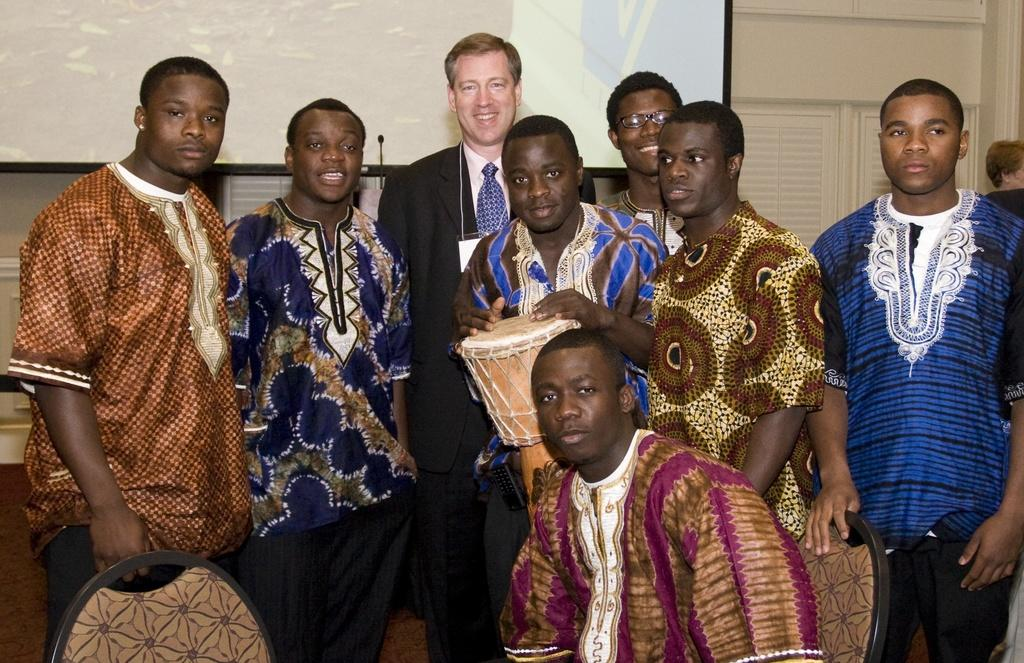How many people are in the image? There is a group of people in the image, but the exact number cannot be determined from the provided facts. What are the people sitting on in the image? There are chairs in the image, which suggests that the people may be sitting on them. What is the main object in the image? There is an object in the image, but its specific nature cannot be determined from the provided facts. What is the purpose of the projector screen in the background of the image? The presence of a projector screen in the background of the image suggests that it might be used for displaying visuals during a presentation or event. What other objects can be seen in the background of the image? There are other objects visible in the background of the image, but their specific nature cannot be determined from the provided facts. What type of spoon is being used by the army in the image? There is no mention of a spoon, army, or any related activities in the image. 